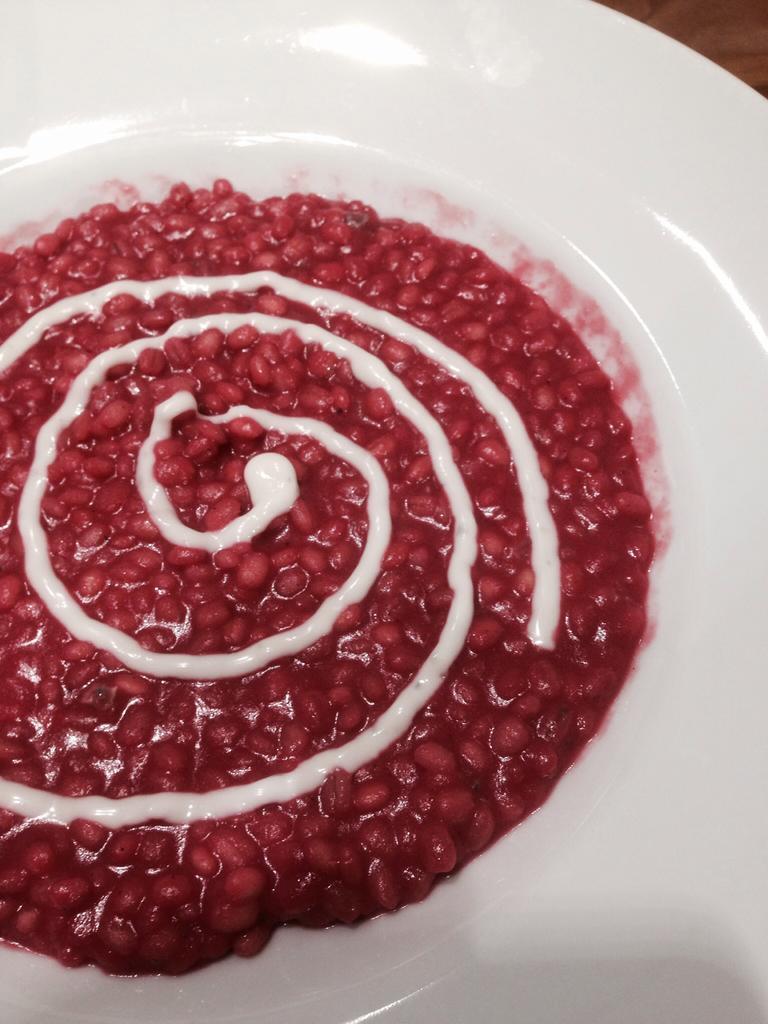How would you summarize this image in a sentence or two? This is a zoomed in picture. In the center there is a white color palette containing some food item. In the background we can see an object seems to be a table. 